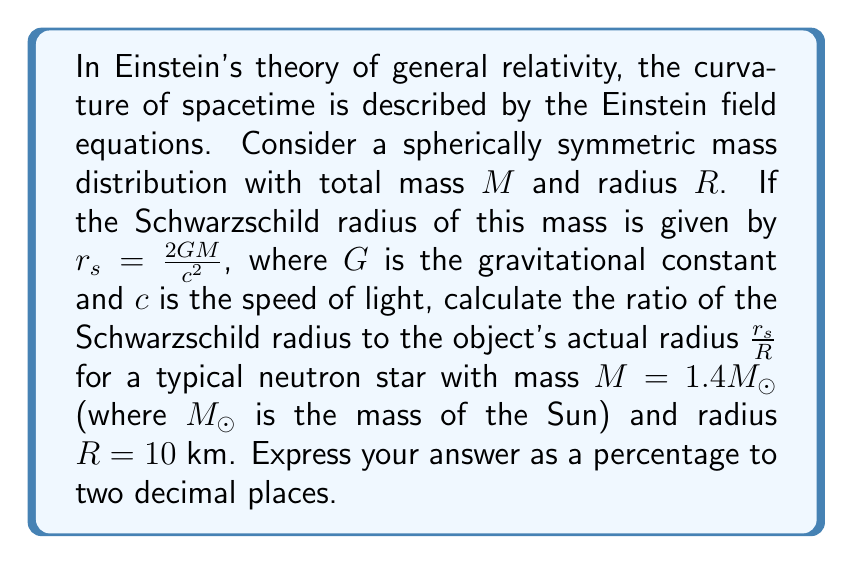Can you solve this math problem? To solve this problem, we'll follow these steps:

1) First, let's recall the formula for the Schwarzschild radius:

   $$r_s = \frac{2GM}{c^2}$$

2) We need to substitute the values for $G$, $M$, and $c$. Let's use these constants:
   
   $G = 6.674 \times 10^{-11} \text{ m}^3 \text{ kg}^{-1} \text{ s}^{-2}$
   $c = 2.998 \times 10^8 \text{ m/s}$
   $M_{\odot} = 1.989 \times 10^{30} \text{ kg}$

3) Calculate the mass of the neutron star:

   $M = 1.4M_{\odot} = 1.4 \times (1.989 \times 10^{30}) = 2.785 \times 10^{30} \text{ kg}$

4) Now, let's substitute these values into the Schwarzschild radius formula:

   $$r_s = \frac{2 \times (6.674 \times 10^{-11}) \times (2.785 \times 10^{30})}{(2.998 \times 10^8)^2}$$

5) Calculating this:

   $$r_s \approx 4.123 \times 10^3 \text{ m} = 4.123 \text{ km}$$

6) Now, we need to find the ratio $\frac{r_s}{R}$:

   $$\frac{r_s}{R} = \frac{4.123 \text{ km}}{10 \text{ km}} = 0.4123$$

7) To express this as a percentage:

   $0.4123 \times 100\% = 41.23\%$

This means the Schwarzschild radius is about 41.23% of the neutron star's actual radius.
Answer: 41.23% 